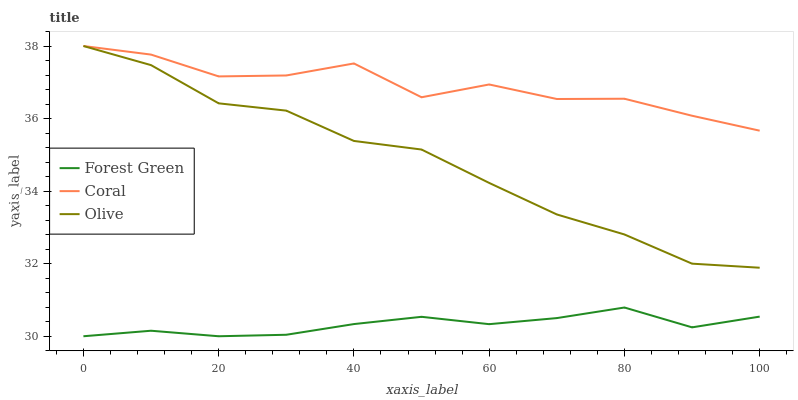Does Forest Green have the minimum area under the curve?
Answer yes or no. Yes. Does Coral have the maximum area under the curve?
Answer yes or no. Yes. Does Coral have the minimum area under the curve?
Answer yes or no. No. Does Forest Green have the maximum area under the curve?
Answer yes or no. No. Is Forest Green the smoothest?
Answer yes or no. Yes. Is Coral the roughest?
Answer yes or no. Yes. Is Coral the smoothest?
Answer yes or no. No. Is Forest Green the roughest?
Answer yes or no. No. Does Coral have the lowest value?
Answer yes or no. No. Does Coral have the highest value?
Answer yes or no. Yes. Does Forest Green have the highest value?
Answer yes or no. No. Is Forest Green less than Coral?
Answer yes or no. Yes. Is Coral greater than Forest Green?
Answer yes or no. Yes. Does Coral intersect Olive?
Answer yes or no. Yes. Is Coral less than Olive?
Answer yes or no. No. Is Coral greater than Olive?
Answer yes or no. No. Does Forest Green intersect Coral?
Answer yes or no. No. 